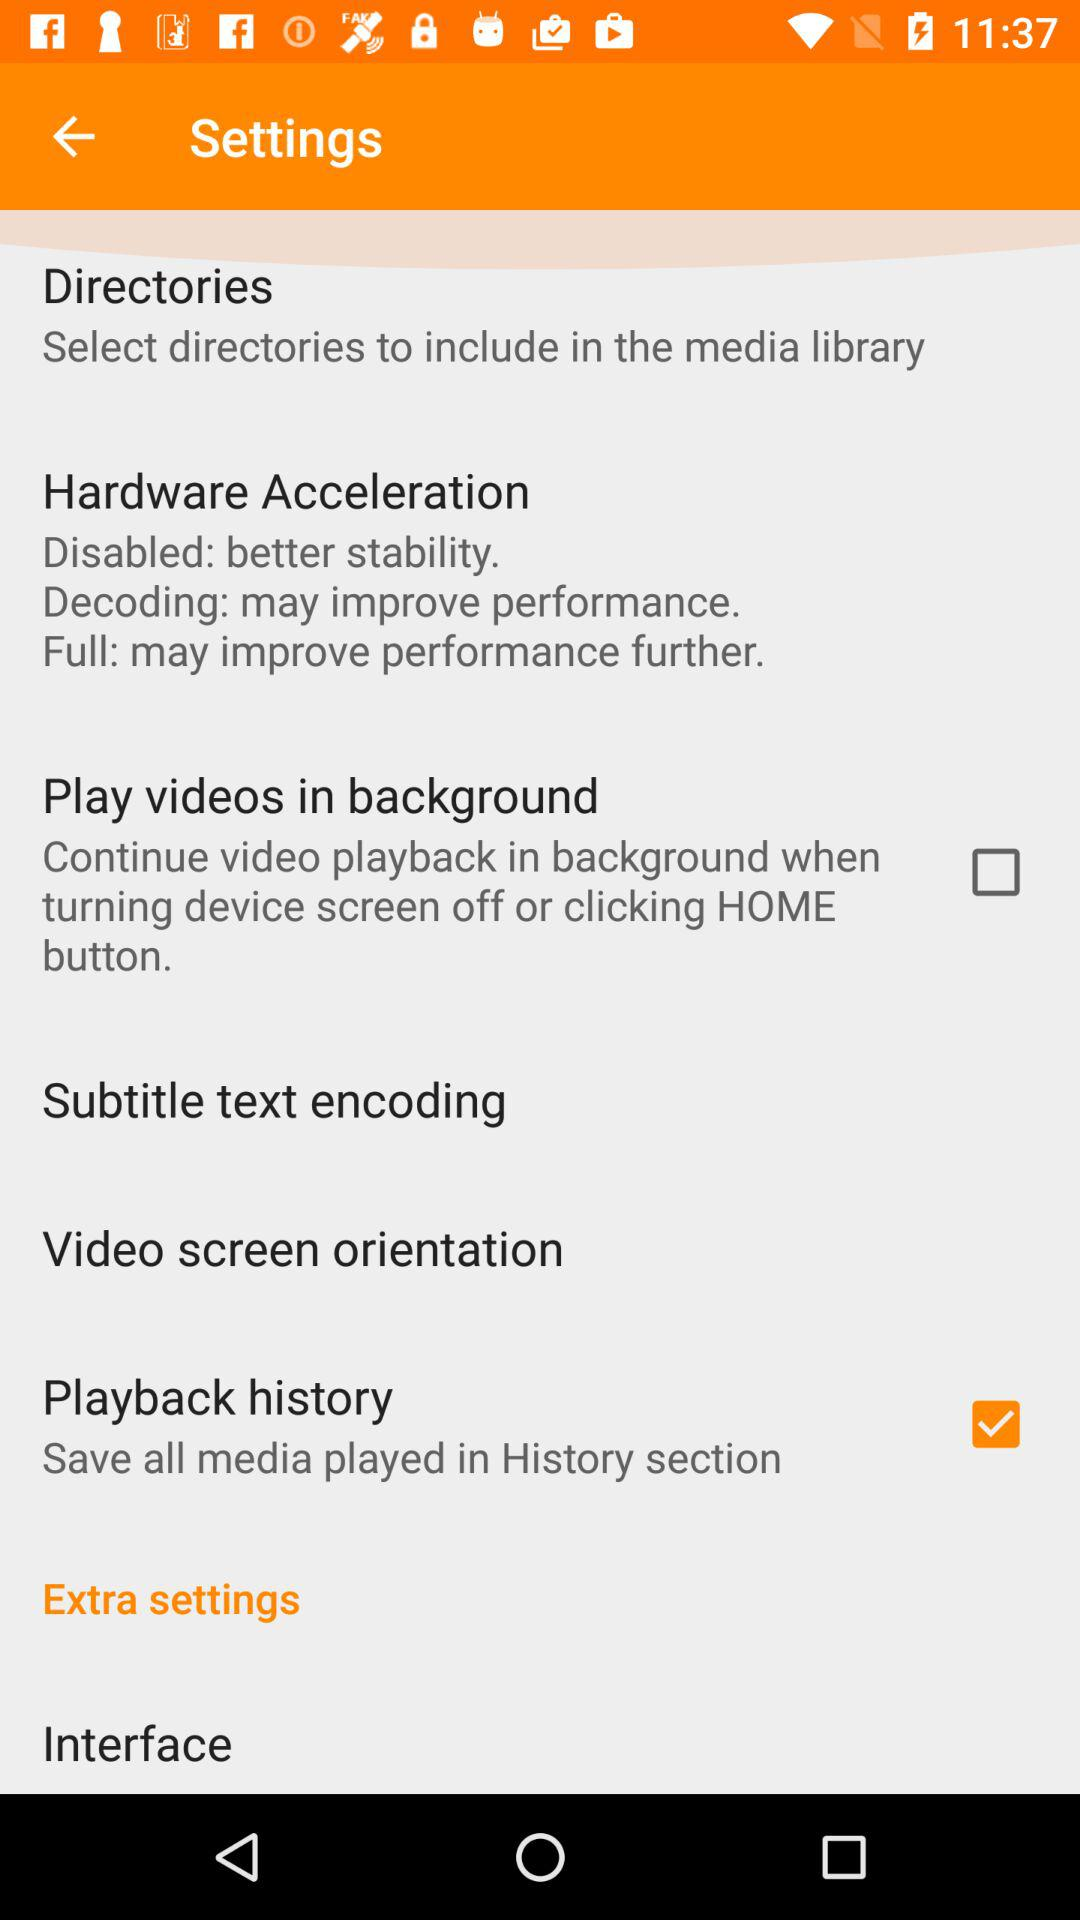How many settings options have a checkbox?
Answer the question using a single word or phrase. 2 